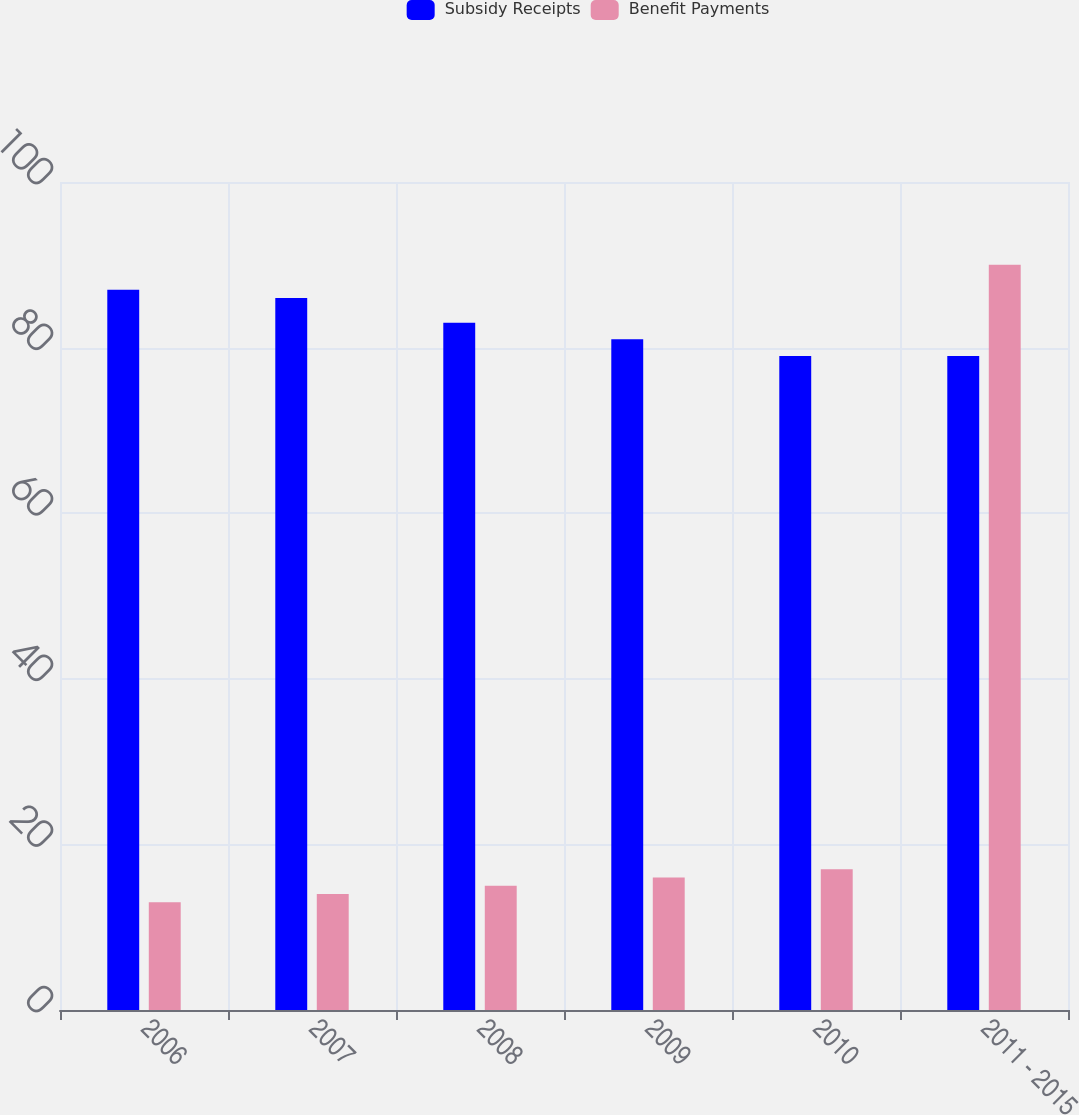<chart> <loc_0><loc_0><loc_500><loc_500><stacked_bar_chart><ecel><fcel>2006<fcel>2007<fcel>2008<fcel>2009<fcel>2010<fcel>2011 - 2015<nl><fcel>Subsidy Receipts<fcel>87<fcel>86<fcel>83<fcel>81<fcel>79<fcel>79<nl><fcel>Benefit Payments<fcel>13<fcel>14<fcel>15<fcel>16<fcel>17<fcel>90<nl></chart> 